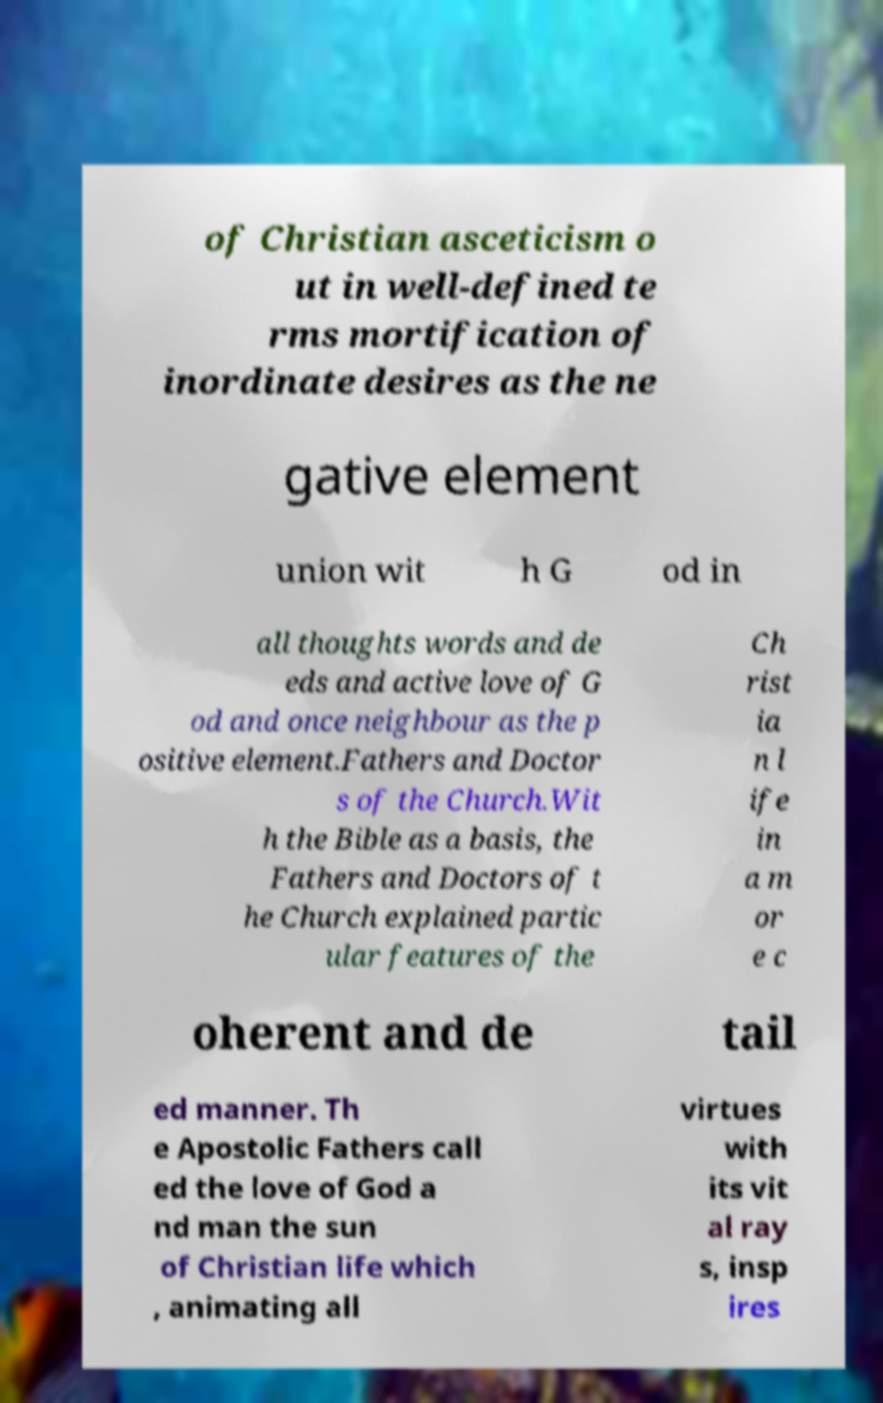Can you accurately transcribe the text from the provided image for me? of Christian asceticism o ut in well-defined te rms mortification of inordinate desires as the ne gative element union wit h G od in all thoughts words and de eds and active love of G od and once neighbour as the p ositive element.Fathers and Doctor s of the Church.Wit h the Bible as a basis, the Fathers and Doctors of t he Church explained partic ular features of the Ch rist ia n l ife in a m or e c oherent and de tail ed manner. Th e Apostolic Fathers call ed the love of God a nd man the sun of Christian life which , animating all virtues with its vit al ray s, insp ires 